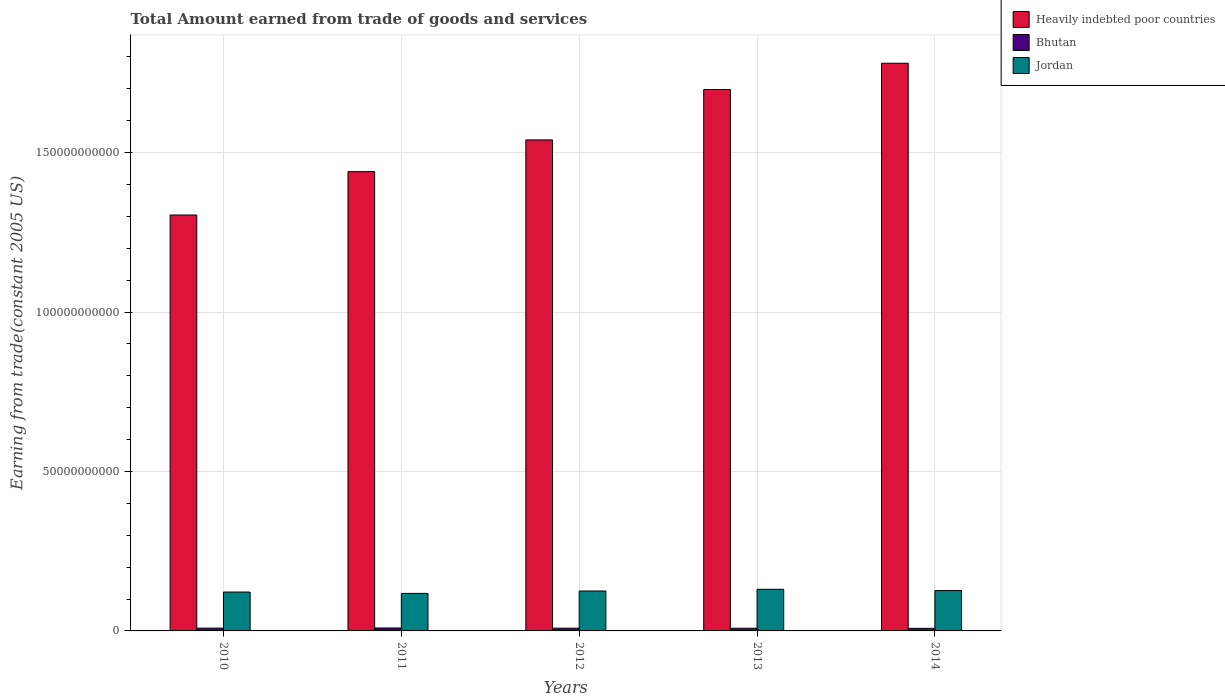How many different coloured bars are there?
Ensure brevity in your answer.  3. Are the number of bars per tick equal to the number of legend labels?
Provide a short and direct response. Yes. How many bars are there on the 2nd tick from the left?
Your answer should be compact. 3. How many bars are there on the 5th tick from the right?
Make the answer very short. 3. In how many cases, is the number of bars for a given year not equal to the number of legend labels?
Offer a very short reply. 0. What is the total amount earned by trading goods and services in Heavily indebted poor countries in 2010?
Your answer should be very brief. 1.30e+11. Across all years, what is the maximum total amount earned by trading goods and services in Heavily indebted poor countries?
Ensure brevity in your answer.  1.78e+11. Across all years, what is the minimum total amount earned by trading goods and services in Bhutan?
Offer a very short reply. 8.09e+08. In which year was the total amount earned by trading goods and services in Jordan minimum?
Give a very brief answer. 2011. What is the total total amount earned by trading goods and services in Jordan in the graph?
Your response must be concise. 6.22e+1. What is the difference between the total amount earned by trading goods and services in Heavily indebted poor countries in 2013 and that in 2014?
Provide a short and direct response. -8.23e+09. What is the difference between the total amount earned by trading goods and services in Jordan in 2011 and the total amount earned by trading goods and services in Bhutan in 2013?
Keep it short and to the point. 1.09e+1. What is the average total amount earned by trading goods and services in Jordan per year?
Make the answer very short. 1.24e+1. In the year 2013, what is the difference between the total amount earned by trading goods and services in Heavily indebted poor countries and total amount earned by trading goods and services in Bhutan?
Offer a terse response. 1.69e+11. In how many years, is the total amount earned by trading goods and services in Heavily indebted poor countries greater than 160000000000 US$?
Give a very brief answer. 2. What is the ratio of the total amount earned by trading goods and services in Jordan in 2012 to that in 2013?
Offer a terse response. 0.96. Is the difference between the total amount earned by trading goods and services in Heavily indebted poor countries in 2013 and 2014 greater than the difference between the total amount earned by trading goods and services in Bhutan in 2013 and 2014?
Your response must be concise. No. What is the difference between the highest and the second highest total amount earned by trading goods and services in Jordan?
Make the answer very short. 3.99e+08. What is the difference between the highest and the lowest total amount earned by trading goods and services in Bhutan?
Provide a short and direct response. 1.10e+08. Is the sum of the total amount earned by trading goods and services in Bhutan in 2012 and 2013 greater than the maximum total amount earned by trading goods and services in Jordan across all years?
Provide a short and direct response. No. What does the 3rd bar from the left in 2010 represents?
Make the answer very short. Jordan. What does the 3rd bar from the right in 2010 represents?
Offer a terse response. Heavily indebted poor countries. Is it the case that in every year, the sum of the total amount earned by trading goods and services in Heavily indebted poor countries and total amount earned by trading goods and services in Jordan is greater than the total amount earned by trading goods and services in Bhutan?
Your answer should be very brief. Yes. Does the graph contain any zero values?
Your answer should be very brief. No. Where does the legend appear in the graph?
Keep it short and to the point. Top right. How many legend labels are there?
Your answer should be compact. 3. What is the title of the graph?
Ensure brevity in your answer.  Total Amount earned from trade of goods and services. What is the label or title of the X-axis?
Offer a terse response. Years. What is the label or title of the Y-axis?
Your answer should be very brief. Earning from trade(constant 2005 US). What is the Earning from trade(constant 2005 US) in Heavily indebted poor countries in 2010?
Your answer should be very brief. 1.30e+11. What is the Earning from trade(constant 2005 US) of Bhutan in 2010?
Your answer should be compact. 8.67e+08. What is the Earning from trade(constant 2005 US) in Jordan in 2010?
Offer a very short reply. 1.22e+1. What is the Earning from trade(constant 2005 US) in Heavily indebted poor countries in 2011?
Your answer should be very brief. 1.44e+11. What is the Earning from trade(constant 2005 US) of Bhutan in 2011?
Keep it short and to the point. 9.19e+08. What is the Earning from trade(constant 2005 US) of Jordan in 2011?
Offer a very short reply. 1.18e+1. What is the Earning from trade(constant 2005 US) of Heavily indebted poor countries in 2012?
Ensure brevity in your answer.  1.54e+11. What is the Earning from trade(constant 2005 US) of Bhutan in 2012?
Ensure brevity in your answer.  8.53e+08. What is the Earning from trade(constant 2005 US) of Jordan in 2012?
Provide a short and direct response. 1.25e+1. What is the Earning from trade(constant 2005 US) in Heavily indebted poor countries in 2013?
Offer a very short reply. 1.70e+11. What is the Earning from trade(constant 2005 US) of Bhutan in 2013?
Offer a very short reply. 8.38e+08. What is the Earning from trade(constant 2005 US) in Jordan in 2013?
Your response must be concise. 1.31e+1. What is the Earning from trade(constant 2005 US) in Heavily indebted poor countries in 2014?
Your answer should be very brief. 1.78e+11. What is the Earning from trade(constant 2005 US) in Bhutan in 2014?
Provide a succinct answer. 8.09e+08. What is the Earning from trade(constant 2005 US) in Jordan in 2014?
Give a very brief answer. 1.27e+1. Across all years, what is the maximum Earning from trade(constant 2005 US) in Heavily indebted poor countries?
Keep it short and to the point. 1.78e+11. Across all years, what is the maximum Earning from trade(constant 2005 US) in Bhutan?
Give a very brief answer. 9.19e+08. Across all years, what is the maximum Earning from trade(constant 2005 US) in Jordan?
Make the answer very short. 1.31e+1. Across all years, what is the minimum Earning from trade(constant 2005 US) of Heavily indebted poor countries?
Offer a terse response. 1.30e+11. Across all years, what is the minimum Earning from trade(constant 2005 US) of Bhutan?
Offer a terse response. 8.09e+08. Across all years, what is the minimum Earning from trade(constant 2005 US) of Jordan?
Provide a short and direct response. 1.18e+1. What is the total Earning from trade(constant 2005 US) of Heavily indebted poor countries in the graph?
Give a very brief answer. 7.76e+11. What is the total Earning from trade(constant 2005 US) of Bhutan in the graph?
Provide a succinct answer. 4.29e+09. What is the total Earning from trade(constant 2005 US) in Jordan in the graph?
Provide a succinct answer. 6.22e+1. What is the difference between the Earning from trade(constant 2005 US) of Heavily indebted poor countries in 2010 and that in 2011?
Keep it short and to the point. -1.36e+1. What is the difference between the Earning from trade(constant 2005 US) of Bhutan in 2010 and that in 2011?
Provide a short and direct response. -5.17e+07. What is the difference between the Earning from trade(constant 2005 US) in Jordan in 2010 and that in 2011?
Offer a very short reply. 4.22e+08. What is the difference between the Earning from trade(constant 2005 US) in Heavily indebted poor countries in 2010 and that in 2012?
Keep it short and to the point. -2.36e+1. What is the difference between the Earning from trade(constant 2005 US) in Bhutan in 2010 and that in 2012?
Give a very brief answer. 1.38e+07. What is the difference between the Earning from trade(constant 2005 US) of Jordan in 2010 and that in 2012?
Provide a succinct answer. -3.24e+08. What is the difference between the Earning from trade(constant 2005 US) in Heavily indebted poor countries in 2010 and that in 2013?
Keep it short and to the point. -3.94e+1. What is the difference between the Earning from trade(constant 2005 US) of Bhutan in 2010 and that in 2013?
Your response must be concise. 2.90e+07. What is the difference between the Earning from trade(constant 2005 US) in Jordan in 2010 and that in 2013?
Your answer should be compact. -8.67e+08. What is the difference between the Earning from trade(constant 2005 US) of Heavily indebted poor countries in 2010 and that in 2014?
Your answer should be compact. -4.76e+1. What is the difference between the Earning from trade(constant 2005 US) in Bhutan in 2010 and that in 2014?
Your answer should be compact. 5.83e+07. What is the difference between the Earning from trade(constant 2005 US) of Jordan in 2010 and that in 2014?
Your answer should be very brief. -4.68e+08. What is the difference between the Earning from trade(constant 2005 US) of Heavily indebted poor countries in 2011 and that in 2012?
Your response must be concise. -9.95e+09. What is the difference between the Earning from trade(constant 2005 US) of Bhutan in 2011 and that in 2012?
Make the answer very short. 6.55e+07. What is the difference between the Earning from trade(constant 2005 US) of Jordan in 2011 and that in 2012?
Ensure brevity in your answer.  -7.46e+08. What is the difference between the Earning from trade(constant 2005 US) in Heavily indebted poor countries in 2011 and that in 2013?
Provide a succinct answer. -2.57e+1. What is the difference between the Earning from trade(constant 2005 US) of Bhutan in 2011 and that in 2013?
Provide a short and direct response. 8.07e+07. What is the difference between the Earning from trade(constant 2005 US) of Jordan in 2011 and that in 2013?
Offer a terse response. -1.29e+09. What is the difference between the Earning from trade(constant 2005 US) of Heavily indebted poor countries in 2011 and that in 2014?
Your answer should be very brief. -3.40e+1. What is the difference between the Earning from trade(constant 2005 US) of Bhutan in 2011 and that in 2014?
Make the answer very short. 1.10e+08. What is the difference between the Earning from trade(constant 2005 US) of Jordan in 2011 and that in 2014?
Your response must be concise. -8.90e+08. What is the difference between the Earning from trade(constant 2005 US) of Heavily indebted poor countries in 2012 and that in 2013?
Offer a very short reply. -1.58e+1. What is the difference between the Earning from trade(constant 2005 US) of Bhutan in 2012 and that in 2013?
Keep it short and to the point. 1.52e+07. What is the difference between the Earning from trade(constant 2005 US) of Jordan in 2012 and that in 2013?
Provide a short and direct response. -5.43e+08. What is the difference between the Earning from trade(constant 2005 US) of Heavily indebted poor countries in 2012 and that in 2014?
Offer a very short reply. -2.40e+1. What is the difference between the Earning from trade(constant 2005 US) in Bhutan in 2012 and that in 2014?
Ensure brevity in your answer.  4.46e+07. What is the difference between the Earning from trade(constant 2005 US) of Jordan in 2012 and that in 2014?
Keep it short and to the point. -1.44e+08. What is the difference between the Earning from trade(constant 2005 US) of Heavily indebted poor countries in 2013 and that in 2014?
Give a very brief answer. -8.23e+09. What is the difference between the Earning from trade(constant 2005 US) of Bhutan in 2013 and that in 2014?
Provide a short and direct response. 2.94e+07. What is the difference between the Earning from trade(constant 2005 US) in Jordan in 2013 and that in 2014?
Your response must be concise. 3.99e+08. What is the difference between the Earning from trade(constant 2005 US) in Heavily indebted poor countries in 2010 and the Earning from trade(constant 2005 US) in Bhutan in 2011?
Your answer should be very brief. 1.29e+11. What is the difference between the Earning from trade(constant 2005 US) of Heavily indebted poor countries in 2010 and the Earning from trade(constant 2005 US) of Jordan in 2011?
Your response must be concise. 1.19e+11. What is the difference between the Earning from trade(constant 2005 US) in Bhutan in 2010 and the Earning from trade(constant 2005 US) in Jordan in 2011?
Provide a succinct answer. -1.09e+1. What is the difference between the Earning from trade(constant 2005 US) in Heavily indebted poor countries in 2010 and the Earning from trade(constant 2005 US) in Bhutan in 2012?
Offer a very short reply. 1.30e+11. What is the difference between the Earning from trade(constant 2005 US) of Heavily indebted poor countries in 2010 and the Earning from trade(constant 2005 US) of Jordan in 2012?
Offer a very short reply. 1.18e+11. What is the difference between the Earning from trade(constant 2005 US) in Bhutan in 2010 and the Earning from trade(constant 2005 US) in Jordan in 2012?
Give a very brief answer. -1.16e+1. What is the difference between the Earning from trade(constant 2005 US) of Heavily indebted poor countries in 2010 and the Earning from trade(constant 2005 US) of Bhutan in 2013?
Provide a succinct answer. 1.30e+11. What is the difference between the Earning from trade(constant 2005 US) of Heavily indebted poor countries in 2010 and the Earning from trade(constant 2005 US) of Jordan in 2013?
Provide a short and direct response. 1.17e+11. What is the difference between the Earning from trade(constant 2005 US) of Bhutan in 2010 and the Earning from trade(constant 2005 US) of Jordan in 2013?
Keep it short and to the point. -1.22e+1. What is the difference between the Earning from trade(constant 2005 US) of Heavily indebted poor countries in 2010 and the Earning from trade(constant 2005 US) of Bhutan in 2014?
Provide a short and direct response. 1.30e+11. What is the difference between the Earning from trade(constant 2005 US) in Heavily indebted poor countries in 2010 and the Earning from trade(constant 2005 US) in Jordan in 2014?
Your answer should be very brief. 1.18e+11. What is the difference between the Earning from trade(constant 2005 US) of Bhutan in 2010 and the Earning from trade(constant 2005 US) of Jordan in 2014?
Provide a short and direct response. -1.18e+1. What is the difference between the Earning from trade(constant 2005 US) in Heavily indebted poor countries in 2011 and the Earning from trade(constant 2005 US) in Bhutan in 2012?
Offer a very short reply. 1.43e+11. What is the difference between the Earning from trade(constant 2005 US) in Heavily indebted poor countries in 2011 and the Earning from trade(constant 2005 US) in Jordan in 2012?
Keep it short and to the point. 1.32e+11. What is the difference between the Earning from trade(constant 2005 US) of Bhutan in 2011 and the Earning from trade(constant 2005 US) of Jordan in 2012?
Keep it short and to the point. -1.16e+1. What is the difference between the Earning from trade(constant 2005 US) in Heavily indebted poor countries in 2011 and the Earning from trade(constant 2005 US) in Bhutan in 2013?
Provide a succinct answer. 1.43e+11. What is the difference between the Earning from trade(constant 2005 US) of Heavily indebted poor countries in 2011 and the Earning from trade(constant 2005 US) of Jordan in 2013?
Keep it short and to the point. 1.31e+11. What is the difference between the Earning from trade(constant 2005 US) in Bhutan in 2011 and the Earning from trade(constant 2005 US) in Jordan in 2013?
Make the answer very short. -1.21e+1. What is the difference between the Earning from trade(constant 2005 US) in Heavily indebted poor countries in 2011 and the Earning from trade(constant 2005 US) in Bhutan in 2014?
Keep it short and to the point. 1.43e+11. What is the difference between the Earning from trade(constant 2005 US) in Heavily indebted poor countries in 2011 and the Earning from trade(constant 2005 US) in Jordan in 2014?
Your response must be concise. 1.31e+11. What is the difference between the Earning from trade(constant 2005 US) of Bhutan in 2011 and the Earning from trade(constant 2005 US) of Jordan in 2014?
Make the answer very short. -1.17e+1. What is the difference between the Earning from trade(constant 2005 US) in Heavily indebted poor countries in 2012 and the Earning from trade(constant 2005 US) in Bhutan in 2013?
Offer a terse response. 1.53e+11. What is the difference between the Earning from trade(constant 2005 US) in Heavily indebted poor countries in 2012 and the Earning from trade(constant 2005 US) in Jordan in 2013?
Your answer should be very brief. 1.41e+11. What is the difference between the Earning from trade(constant 2005 US) of Bhutan in 2012 and the Earning from trade(constant 2005 US) of Jordan in 2013?
Provide a short and direct response. -1.22e+1. What is the difference between the Earning from trade(constant 2005 US) in Heavily indebted poor countries in 2012 and the Earning from trade(constant 2005 US) in Bhutan in 2014?
Offer a terse response. 1.53e+11. What is the difference between the Earning from trade(constant 2005 US) in Heavily indebted poor countries in 2012 and the Earning from trade(constant 2005 US) in Jordan in 2014?
Ensure brevity in your answer.  1.41e+11. What is the difference between the Earning from trade(constant 2005 US) in Bhutan in 2012 and the Earning from trade(constant 2005 US) in Jordan in 2014?
Your response must be concise. -1.18e+1. What is the difference between the Earning from trade(constant 2005 US) in Heavily indebted poor countries in 2013 and the Earning from trade(constant 2005 US) in Bhutan in 2014?
Ensure brevity in your answer.  1.69e+11. What is the difference between the Earning from trade(constant 2005 US) of Heavily indebted poor countries in 2013 and the Earning from trade(constant 2005 US) of Jordan in 2014?
Your answer should be compact. 1.57e+11. What is the difference between the Earning from trade(constant 2005 US) of Bhutan in 2013 and the Earning from trade(constant 2005 US) of Jordan in 2014?
Offer a very short reply. -1.18e+1. What is the average Earning from trade(constant 2005 US) of Heavily indebted poor countries per year?
Offer a terse response. 1.55e+11. What is the average Earning from trade(constant 2005 US) in Bhutan per year?
Ensure brevity in your answer.  8.57e+08. What is the average Earning from trade(constant 2005 US) of Jordan per year?
Offer a very short reply. 1.24e+1. In the year 2010, what is the difference between the Earning from trade(constant 2005 US) in Heavily indebted poor countries and Earning from trade(constant 2005 US) in Bhutan?
Offer a very short reply. 1.30e+11. In the year 2010, what is the difference between the Earning from trade(constant 2005 US) in Heavily indebted poor countries and Earning from trade(constant 2005 US) in Jordan?
Your response must be concise. 1.18e+11. In the year 2010, what is the difference between the Earning from trade(constant 2005 US) of Bhutan and Earning from trade(constant 2005 US) of Jordan?
Give a very brief answer. -1.13e+1. In the year 2011, what is the difference between the Earning from trade(constant 2005 US) of Heavily indebted poor countries and Earning from trade(constant 2005 US) of Bhutan?
Your answer should be very brief. 1.43e+11. In the year 2011, what is the difference between the Earning from trade(constant 2005 US) of Heavily indebted poor countries and Earning from trade(constant 2005 US) of Jordan?
Offer a terse response. 1.32e+11. In the year 2011, what is the difference between the Earning from trade(constant 2005 US) in Bhutan and Earning from trade(constant 2005 US) in Jordan?
Offer a very short reply. -1.08e+1. In the year 2012, what is the difference between the Earning from trade(constant 2005 US) in Heavily indebted poor countries and Earning from trade(constant 2005 US) in Bhutan?
Provide a short and direct response. 1.53e+11. In the year 2012, what is the difference between the Earning from trade(constant 2005 US) in Heavily indebted poor countries and Earning from trade(constant 2005 US) in Jordan?
Your answer should be very brief. 1.41e+11. In the year 2012, what is the difference between the Earning from trade(constant 2005 US) of Bhutan and Earning from trade(constant 2005 US) of Jordan?
Keep it short and to the point. -1.17e+1. In the year 2013, what is the difference between the Earning from trade(constant 2005 US) of Heavily indebted poor countries and Earning from trade(constant 2005 US) of Bhutan?
Keep it short and to the point. 1.69e+11. In the year 2013, what is the difference between the Earning from trade(constant 2005 US) of Heavily indebted poor countries and Earning from trade(constant 2005 US) of Jordan?
Provide a short and direct response. 1.57e+11. In the year 2013, what is the difference between the Earning from trade(constant 2005 US) in Bhutan and Earning from trade(constant 2005 US) in Jordan?
Offer a terse response. -1.22e+1. In the year 2014, what is the difference between the Earning from trade(constant 2005 US) of Heavily indebted poor countries and Earning from trade(constant 2005 US) of Bhutan?
Ensure brevity in your answer.  1.77e+11. In the year 2014, what is the difference between the Earning from trade(constant 2005 US) in Heavily indebted poor countries and Earning from trade(constant 2005 US) in Jordan?
Offer a very short reply. 1.65e+11. In the year 2014, what is the difference between the Earning from trade(constant 2005 US) of Bhutan and Earning from trade(constant 2005 US) of Jordan?
Your response must be concise. -1.18e+1. What is the ratio of the Earning from trade(constant 2005 US) of Heavily indebted poor countries in 2010 to that in 2011?
Make the answer very short. 0.91. What is the ratio of the Earning from trade(constant 2005 US) in Bhutan in 2010 to that in 2011?
Provide a short and direct response. 0.94. What is the ratio of the Earning from trade(constant 2005 US) of Jordan in 2010 to that in 2011?
Offer a very short reply. 1.04. What is the ratio of the Earning from trade(constant 2005 US) in Heavily indebted poor countries in 2010 to that in 2012?
Keep it short and to the point. 0.85. What is the ratio of the Earning from trade(constant 2005 US) in Bhutan in 2010 to that in 2012?
Your answer should be compact. 1.02. What is the ratio of the Earning from trade(constant 2005 US) of Jordan in 2010 to that in 2012?
Offer a terse response. 0.97. What is the ratio of the Earning from trade(constant 2005 US) of Heavily indebted poor countries in 2010 to that in 2013?
Your answer should be very brief. 0.77. What is the ratio of the Earning from trade(constant 2005 US) in Bhutan in 2010 to that in 2013?
Offer a very short reply. 1.03. What is the ratio of the Earning from trade(constant 2005 US) in Jordan in 2010 to that in 2013?
Provide a short and direct response. 0.93. What is the ratio of the Earning from trade(constant 2005 US) of Heavily indebted poor countries in 2010 to that in 2014?
Make the answer very short. 0.73. What is the ratio of the Earning from trade(constant 2005 US) in Bhutan in 2010 to that in 2014?
Offer a terse response. 1.07. What is the ratio of the Earning from trade(constant 2005 US) in Jordan in 2010 to that in 2014?
Offer a terse response. 0.96. What is the ratio of the Earning from trade(constant 2005 US) of Heavily indebted poor countries in 2011 to that in 2012?
Ensure brevity in your answer.  0.94. What is the ratio of the Earning from trade(constant 2005 US) in Bhutan in 2011 to that in 2012?
Make the answer very short. 1.08. What is the ratio of the Earning from trade(constant 2005 US) in Jordan in 2011 to that in 2012?
Your answer should be very brief. 0.94. What is the ratio of the Earning from trade(constant 2005 US) of Heavily indebted poor countries in 2011 to that in 2013?
Provide a short and direct response. 0.85. What is the ratio of the Earning from trade(constant 2005 US) of Bhutan in 2011 to that in 2013?
Provide a short and direct response. 1.1. What is the ratio of the Earning from trade(constant 2005 US) of Jordan in 2011 to that in 2013?
Your response must be concise. 0.9. What is the ratio of the Earning from trade(constant 2005 US) of Heavily indebted poor countries in 2011 to that in 2014?
Offer a terse response. 0.81. What is the ratio of the Earning from trade(constant 2005 US) in Bhutan in 2011 to that in 2014?
Your answer should be compact. 1.14. What is the ratio of the Earning from trade(constant 2005 US) of Jordan in 2011 to that in 2014?
Offer a very short reply. 0.93. What is the ratio of the Earning from trade(constant 2005 US) in Heavily indebted poor countries in 2012 to that in 2013?
Offer a very short reply. 0.91. What is the ratio of the Earning from trade(constant 2005 US) of Bhutan in 2012 to that in 2013?
Your answer should be compact. 1.02. What is the ratio of the Earning from trade(constant 2005 US) of Jordan in 2012 to that in 2013?
Your response must be concise. 0.96. What is the ratio of the Earning from trade(constant 2005 US) in Heavily indebted poor countries in 2012 to that in 2014?
Your answer should be compact. 0.86. What is the ratio of the Earning from trade(constant 2005 US) in Bhutan in 2012 to that in 2014?
Your answer should be compact. 1.06. What is the ratio of the Earning from trade(constant 2005 US) of Heavily indebted poor countries in 2013 to that in 2014?
Provide a succinct answer. 0.95. What is the ratio of the Earning from trade(constant 2005 US) of Bhutan in 2013 to that in 2014?
Your response must be concise. 1.04. What is the ratio of the Earning from trade(constant 2005 US) of Jordan in 2013 to that in 2014?
Your answer should be very brief. 1.03. What is the difference between the highest and the second highest Earning from trade(constant 2005 US) of Heavily indebted poor countries?
Your answer should be very brief. 8.23e+09. What is the difference between the highest and the second highest Earning from trade(constant 2005 US) in Bhutan?
Offer a terse response. 5.17e+07. What is the difference between the highest and the second highest Earning from trade(constant 2005 US) of Jordan?
Offer a terse response. 3.99e+08. What is the difference between the highest and the lowest Earning from trade(constant 2005 US) of Heavily indebted poor countries?
Make the answer very short. 4.76e+1. What is the difference between the highest and the lowest Earning from trade(constant 2005 US) in Bhutan?
Provide a short and direct response. 1.10e+08. What is the difference between the highest and the lowest Earning from trade(constant 2005 US) of Jordan?
Your answer should be compact. 1.29e+09. 